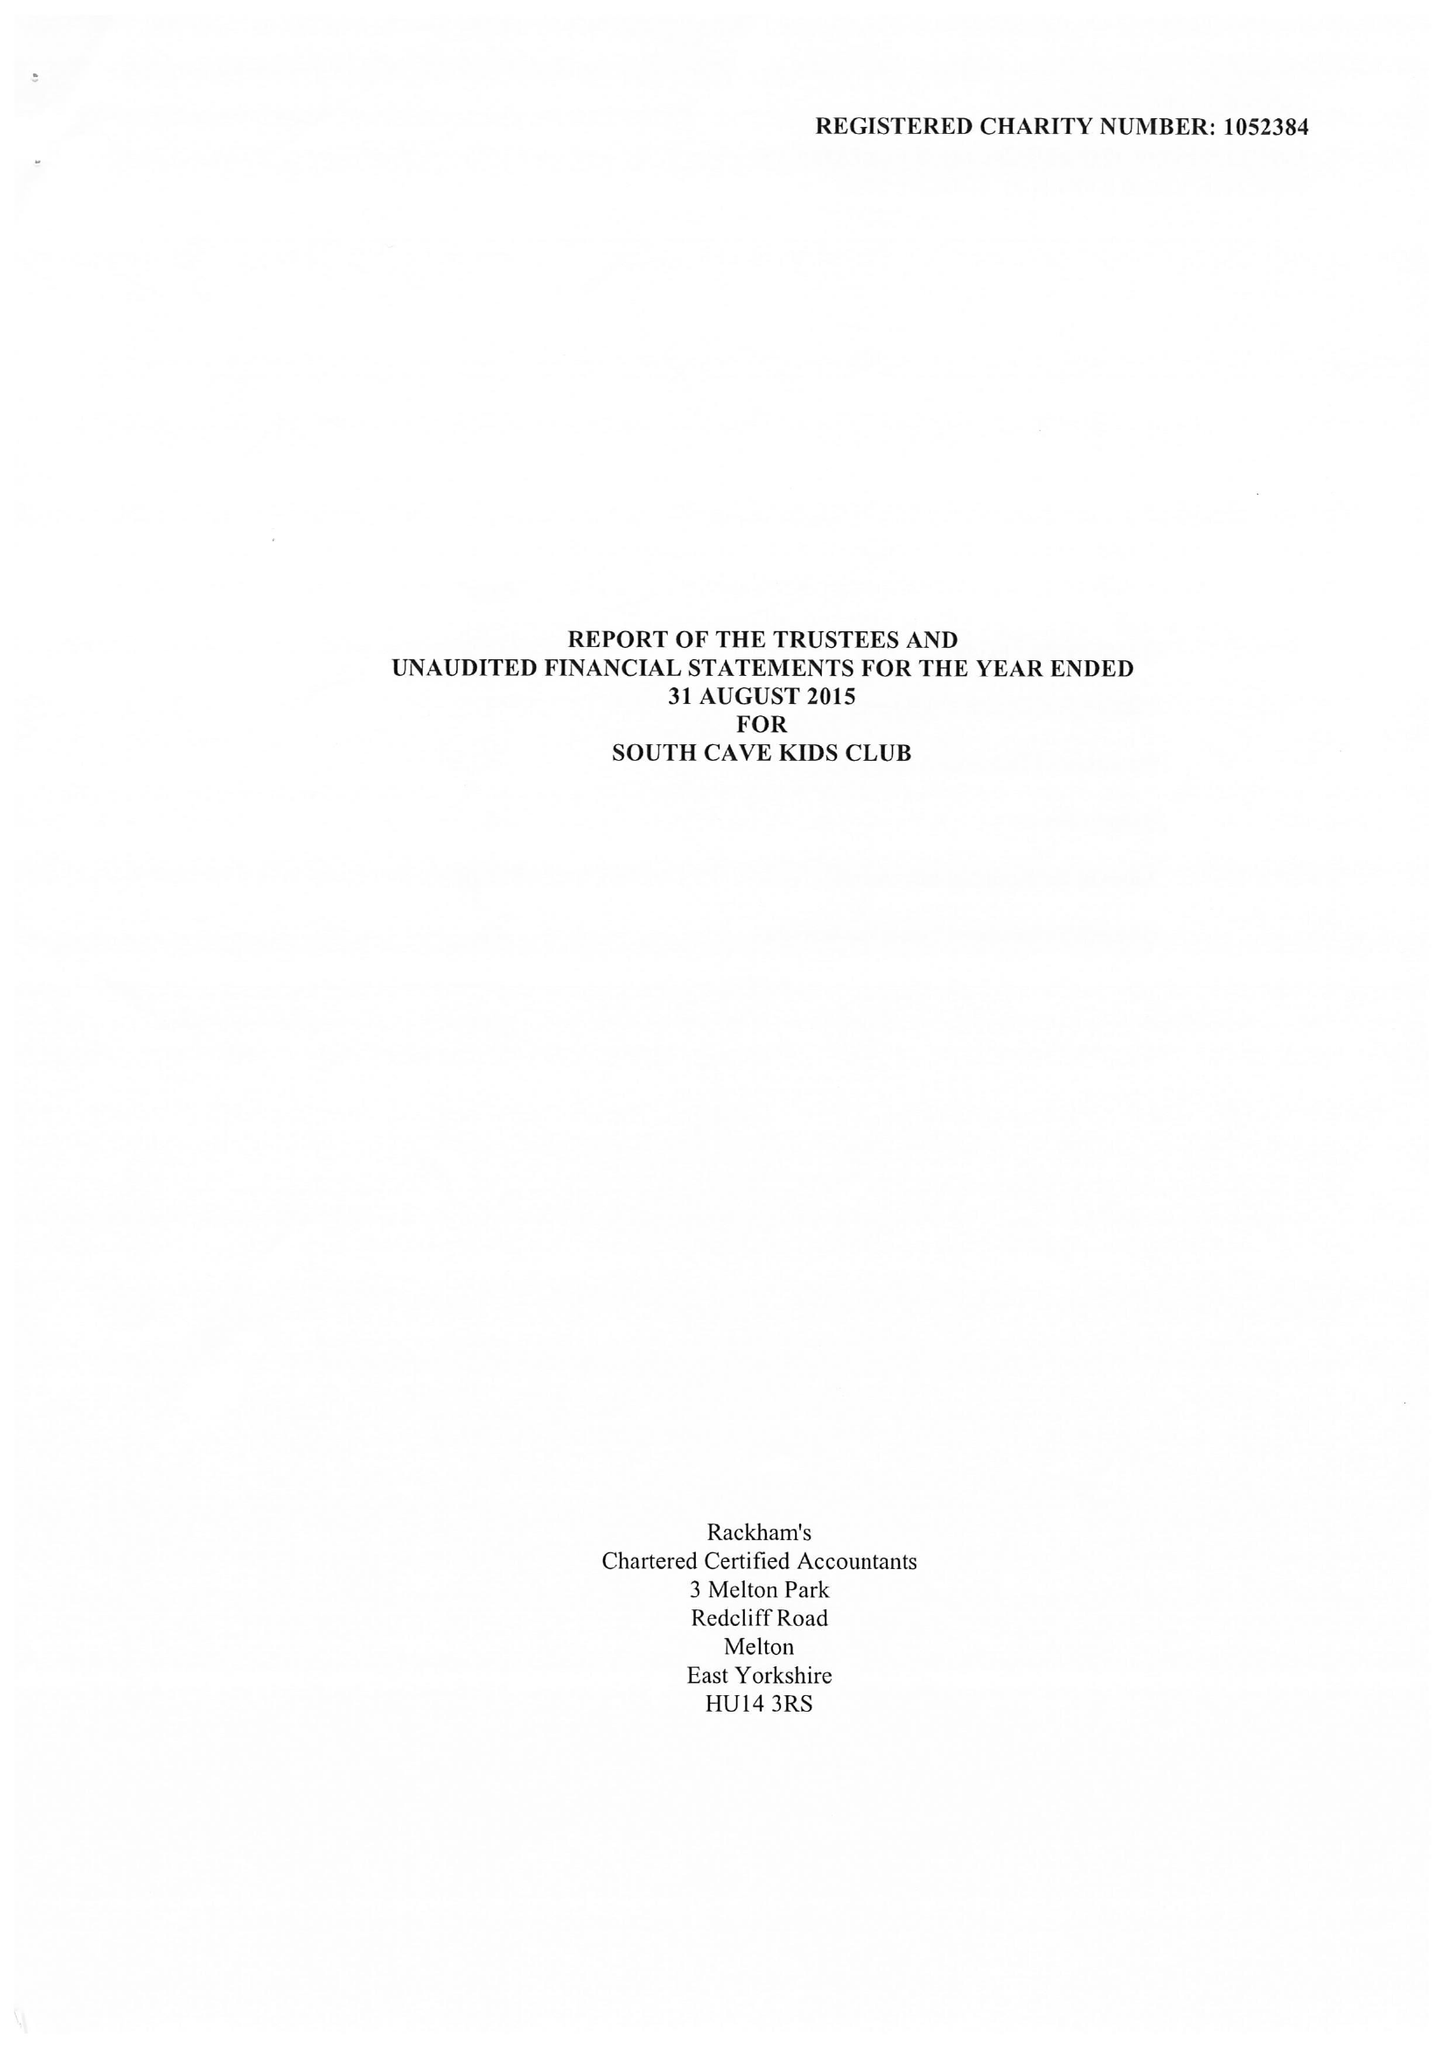What is the value for the charity_name?
Answer the question using a single word or phrase. South Cave Kids Club 